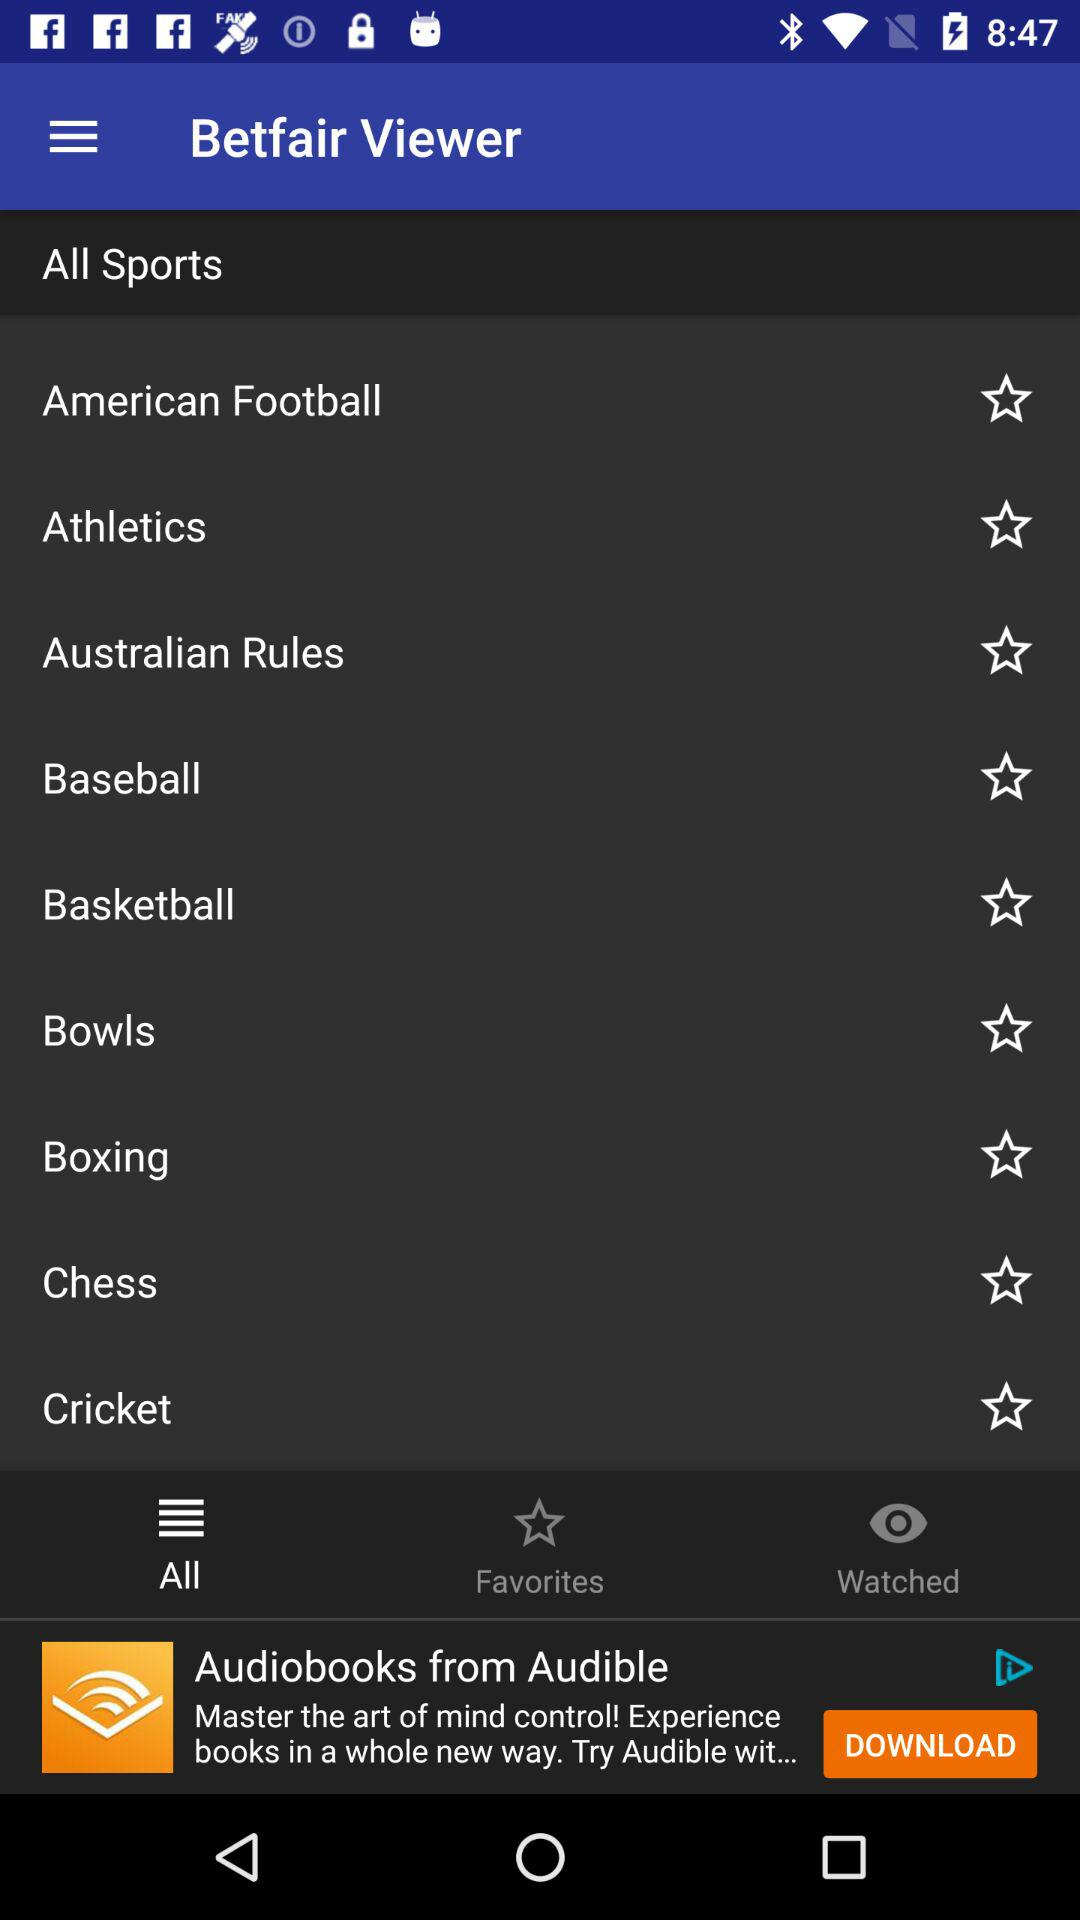What is the name of the application? The name of the application is "Betfair Viewer". 